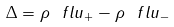<formula> <loc_0><loc_0><loc_500><loc_500>\Delta = \rho ^ { \ } f l u _ { + } - \rho ^ { \ } f l u _ { - }</formula> 